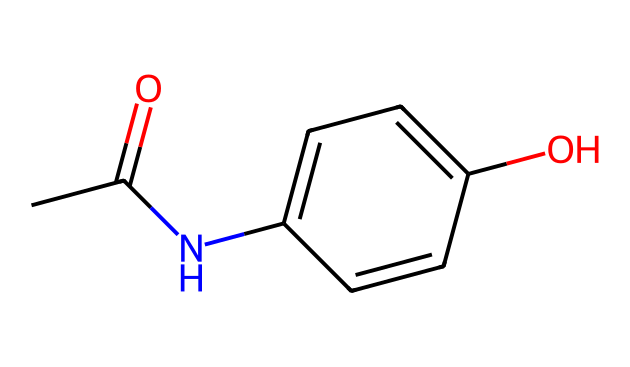What is the molecular formula of acetaminophen? The molecular formula can be derived from counting the atoms in the SMILES representation. The structure includes 8 carbon atoms (C), 9 hydrogen atoms (H), 1 nitrogen atom (N), and 2 oxygen atoms (O). Thus, the molecular formula is C8H9NO2.
Answer: C8H9NO2 How many rings are present in the structure? In the SMILES representation, there are no indications of ring structures as there are no 'c' (indicating a cyclic structure) numbers showing connectivity that would suggest a ring. Therefore, there are 0 rings in the structure.
Answer: 0 What functional groups can be identified in acetaminophen? From the SMILES, we can identify an amide group (CC(=O)N) and a hydroxyl group (O) within the structure. Therefore, the functional groups present are an amide and a phenolic -OH group.
Answer: amide and hydroxyl How many hydrogen atoms are attached to the carbon atoms in the aromatic ring? In the given structure, the aromatic ring is denoted by 'c', which implies that each carbon typically connects to one hydrogen atom. Considering interactions with the nitrogen and the hydroxyl group, there are 4 hydrogen atoms still attached to the carbon atoms in the aromatic ring.
Answer: 4 What type of medicinal effect does acetaminophen have based on its structure? The structure of acetaminophen, characterized by the presence of the amide and phenolic groups, is known for analgesic (pain-relieving) and antipyretic (fever-reducing) properties. These functional groups allow it to interact with biological targets effectively, leading to these medicinal effects.
Answer: analgesic and antipyretic What is the significance of the carbonyl group in this molecule? The carbonyl group (C=O) found in the amide portion of the acetaminophen molecule is crucial for its biological activity, as it contributes to the molecule's ability to undergo metabolic transformations and interact with enzymes that mediate pain and fever responses in the body.
Answer: biological activity 